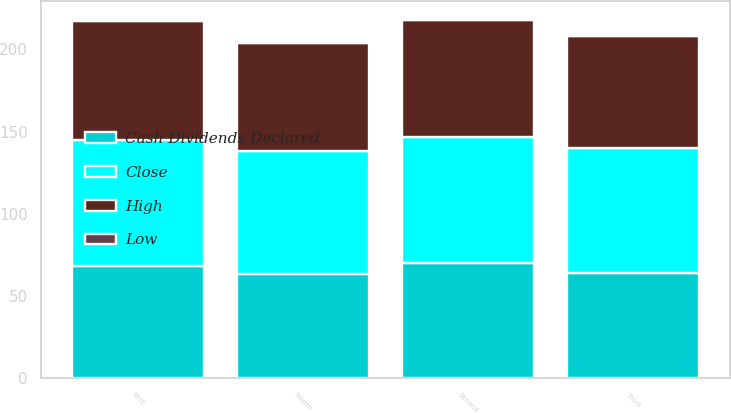Convert chart. <chart><loc_0><loc_0><loc_500><loc_500><stacked_bar_chart><ecel><fcel>First<fcel>Second<fcel>Third<fcel>Fourth<nl><fcel>Close<fcel>76.41<fcel>76.15<fcel>75.99<fcel>74.56<nl><fcel>Cash Dividends Declared<fcel>68.6<fcel>70.31<fcel>64<fcel>63.54<nl><fcel>High<fcel>71.97<fcel>71.58<fcel>68.1<fcel>65.65<nl><fcel>Low<fcel>0.55<fcel>0.63<fcel>0.63<fcel>0.63<nl></chart> 